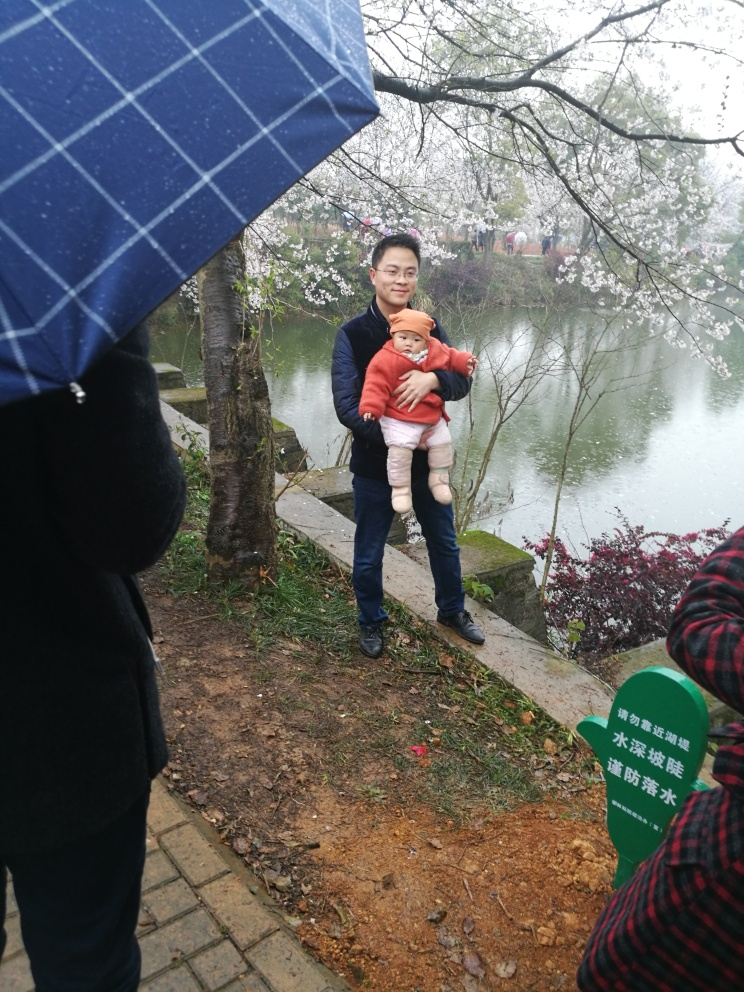What can we infer about the weather and the season from this image? From the subdued lighting and the presence of an umbrella, it appears to be an overcast or rainy day. The cherry blossoms suggest that it is springtime, a season often associated with such floral blooms. 